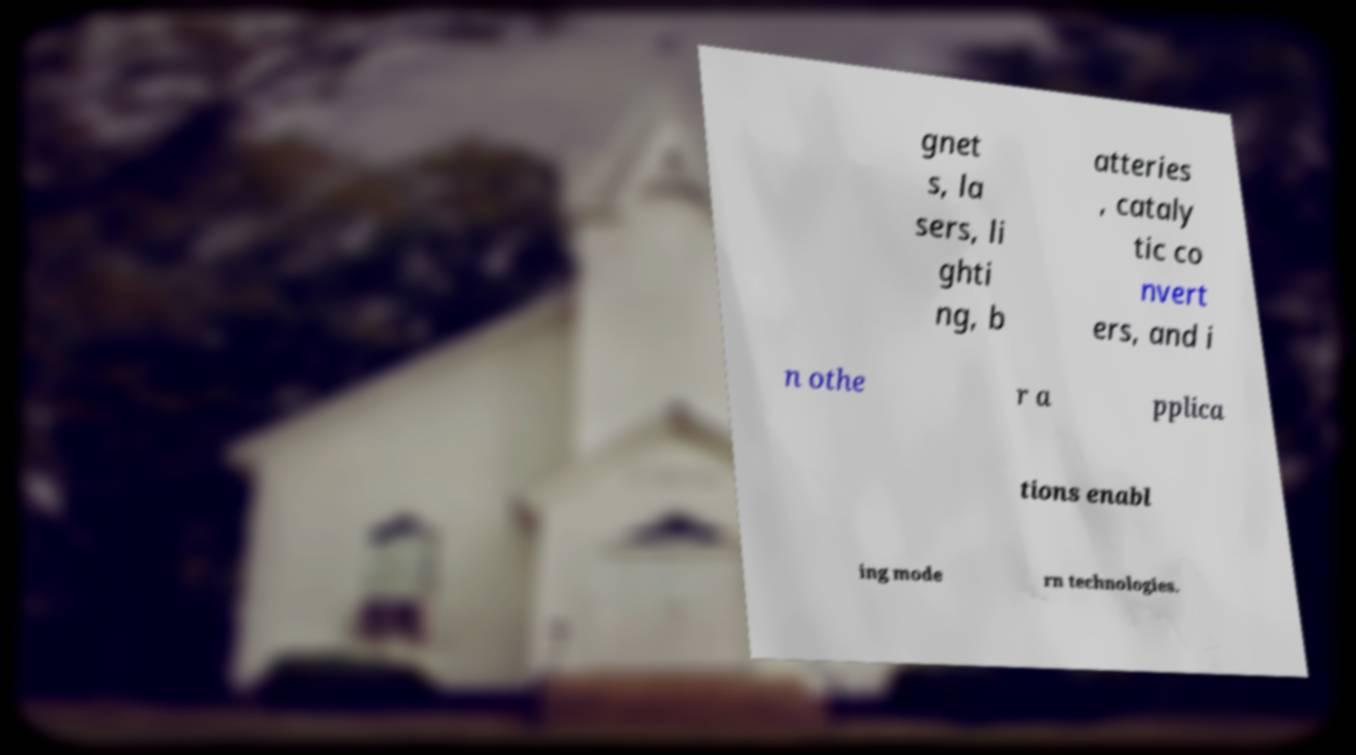Please identify and transcribe the text found in this image. gnet s, la sers, li ghti ng, b atteries , cataly tic co nvert ers, and i n othe r a pplica tions enabl ing mode rn technologies. 